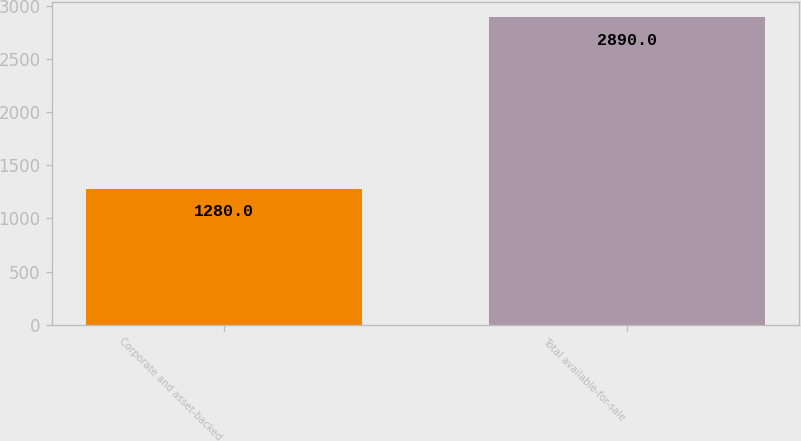Convert chart to OTSL. <chart><loc_0><loc_0><loc_500><loc_500><bar_chart><fcel>Corporate and asset-backed<fcel>Total available-for-sale<nl><fcel>1280<fcel>2890<nl></chart> 